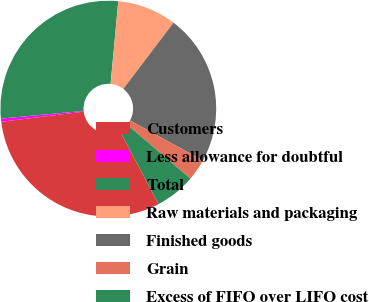Convert chart. <chart><loc_0><loc_0><loc_500><loc_500><pie_chart><fcel>Customers<fcel>Less allowance for doubtful<fcel>Total<fcel>Raw materials and packaging<fcel>Finished goods<fcel>Grain<fcel>Excess of FIFO over LIFO cost<nl><fcel>30.75%<fcel>0.47%<fcel>27.95%<fcel>8.86%<fcel>22.64%<fcel>3.27%<fcel>6.06%<nl></chart> 